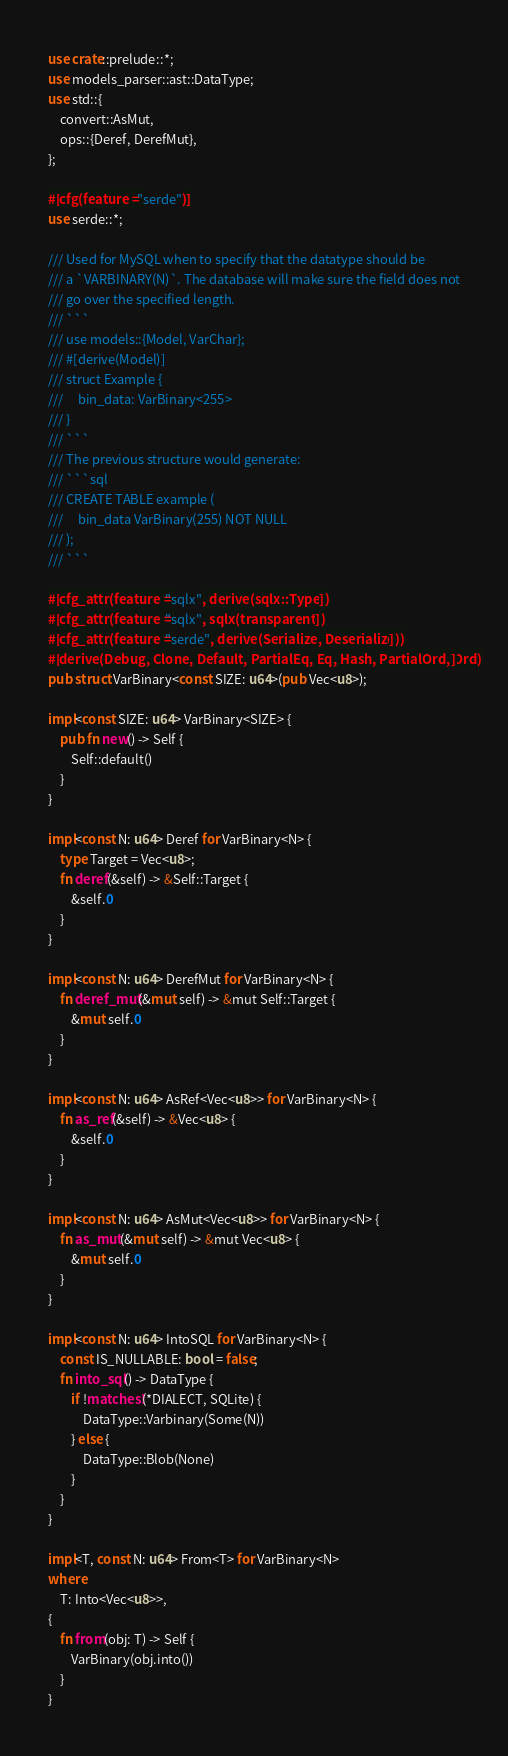Convert code to text. <code><loc_0><loc_0><loc_500><loc_500><_Rust_>use crate::prelude::*;
use models_parser::ast::DataType;
use std::{
    convert::AsMut,
    ops::{Deref, DerefMut},
};

#[cfg(feature = "serde")]
use serde::*;

/// Used for MySQL when to specify that the datatype should be
/// a `VARBINARY(N)`. The database will make sure the field does not
/// go over the specified length.
/// ```
/// use models::{Model, VarChar};
/// #[derive(Model)]
/// struct Example {
///     bin_data: VarBinary<255>
/// }
/// ```
/// The previous structure would generate:
/// ```sql
/// CREATE TABLE example (
///     bin_data VarBinary(255) NOT NULL
/// );
/// ```

#[cfg_attr(feature = "sqlx", derive(sqlx::Type))]
#[cfg_attr(feature = "sqlx", sqlx(transparent))]
#[cfg_attr(feature = "serde", derive(Serialize, Deserialize))]
#[derive(Debug, Clone, Default, PartialEq, Eq, Hash, PartialOrd, Ord)]
pub struct VarBinary<const SIZE: u64>(pub Vec<u8>);

impl<const SIZE: u64> VarBinary<SIZE> {
    pub fn new() -> Self {
        Self::default()
    }
}

impl<const N: u64> Deref for VarBinary<N> {
    type Target = Vec<u8>;
    fn deref(&self) -> &Self::Target {
        &self.0
    }
}

impl<const N: u64> DerefMut for VarBinary<N> {
    fn deref_mut(&mut self) -> &mut Self::Target {
        &mut self.0
    }
}

impl<const N: u64> AsRef<Vec<u8>> for VarBinary<N> {
    fn as_ref(&self) -> &Vec<u8> {
        &self.0
    }
}

impl<const N: u64> AsMut<Vec<u8>> for VarBinary<N> {
    fn as_mut(&mut self) -> &mut Vec<u8> {
        &mut self.0
    }
}

impl<const N: u64> IntoSQL for VarBinary<N> {
    const IS_NULLABLE: bool = false;
    fn into_sql() -> DataType {
        if !matches!(*DIALECT, SQLite) {
            DataType::Varbinary(Some(N))
        } else {
            DataType::Blob(None)
        }
    }
}

impl<T, const N: u64> From<T> for VarBinary<N>
where
    T: Into<Vec<u8>>,
{
    fn from(obj: T) -> Self {
        VarBinary(obj.into())
    }
}
</code> 